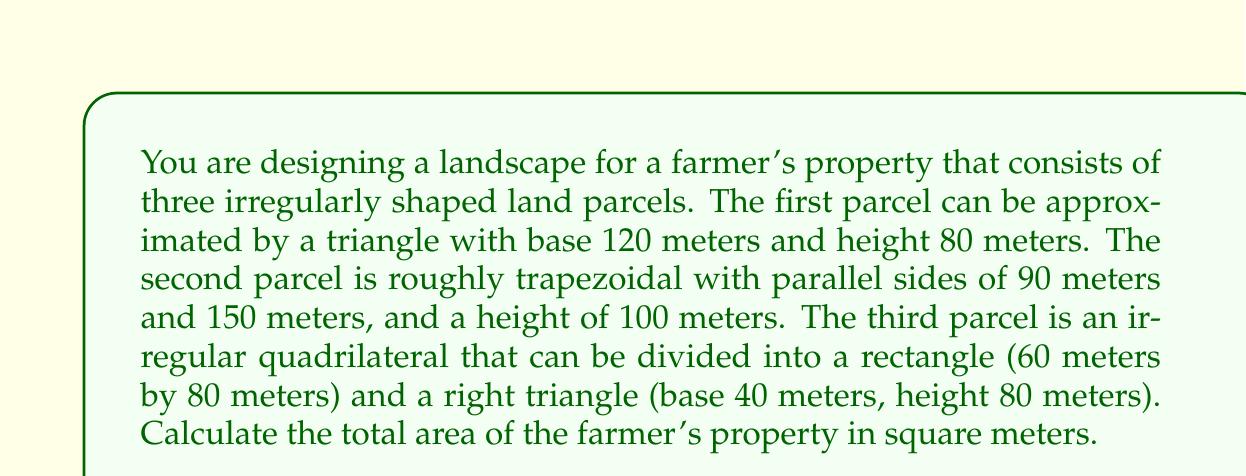Provide a solution to this math problem. Let's calculate the area of each parcel separately:

1. First parcel (triangle):
   Area = $\frac{1}{2} \times base \times height$
   $$A_1 = \frac{1}{2} \times 120 \times 80 = 4,800 \text{ m}^2$$

2. Second parcel (trapezoid):
   Area = $\frac{1}{2} \times (a + b) \times h$, where a and b are parallel sides and h is height
   $$A_2 = \frac{1}{2} \times (90 + 150) \times 100 = 12,000 \text{ m}^2$$

3. Third parcel (irregular quadrilateral):
   Rectangle area: $60 \times 80 = 4,800 \text{ m}^2$
   Right triangle area: $\frac{1}{2} \times 40 \times 80 = 1,600 \text{ m}^2$
   $$A_3 = 4,800 + 1,600 = 6,400 \text{ m}^2$$

Total area of the farmer's property:
$$A_{total} = A_1 + A_2 + A_3 = 4,800 + 12,000 + 6,400 = 23,200 \text{ m}^2$$
Answer: 23,200 m² 